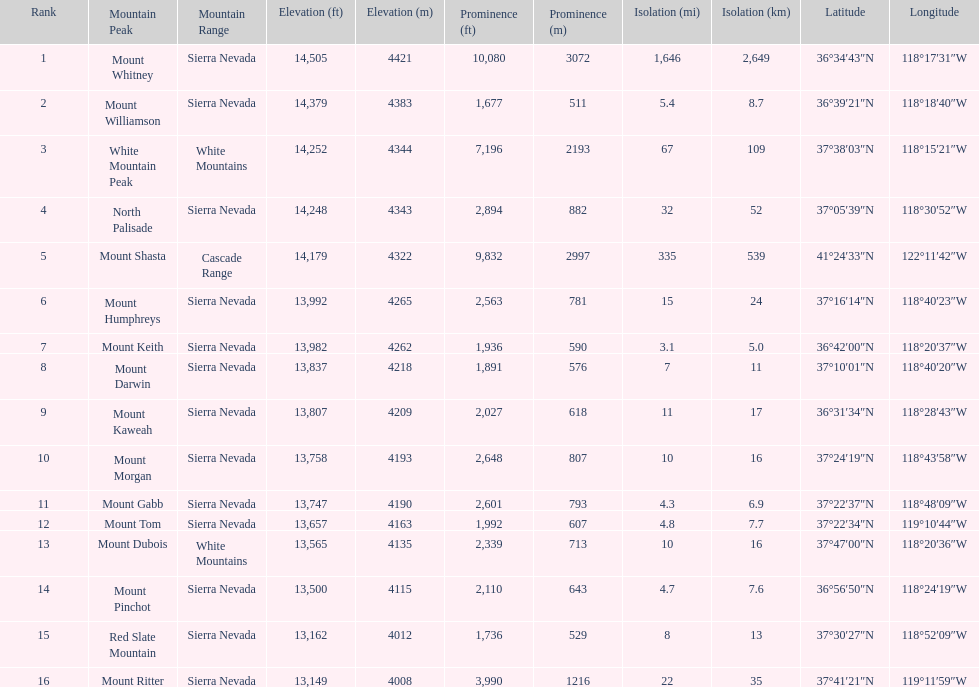What is the only mountain peak listed for the cascade range? Mount Shasta. 